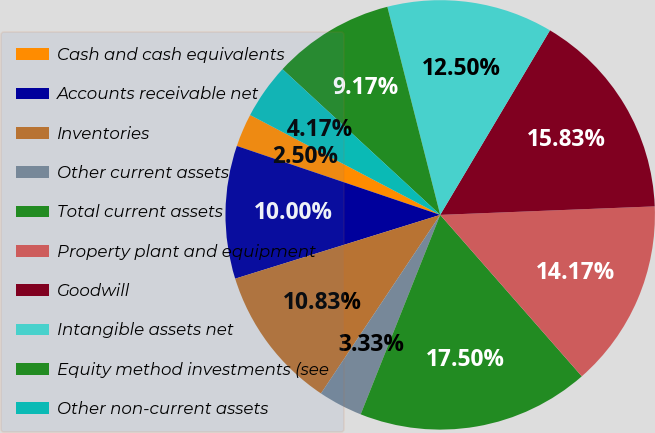Convert chart to OTSL. <chart><loc_0><loc_0><loc_500><loc_500><pie_chart><fcel>Cash and cash equivalents<fcel>Accounts receivable net<fcel>Inventories<fcel>Other current assets<fcel>Total current assets<fcel>Property plant and equipment<fcel>Goodwill<fcel>Intangible assets net<fcel>Equity method investments (see<fcel>Other non-current assets<nl><fcel>2.5%<fcel>10.0%<fcel>10.83%<fcel>3.33%<fcel>17.5%<fcel>14.17%<fcel>15.83%<fcel>12.5%<fcel>9.17%<fcel>4.17%<nl></chart> 